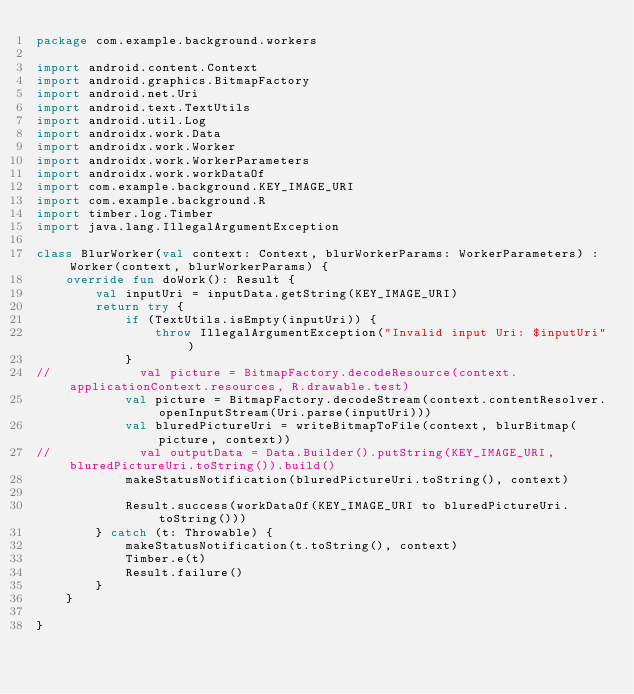<code> <loc_0><loc_0><loc_500><loc_500><_Kotlin_>package com.example.background.workers

import android.content.Context
import android.graphics.BitmapFactory
import android.net.Uri
import android.text.TextUtils
import android.util.Log
import androidx.work.Data
import androidx.work.Worker
import androidx.work.WorkerParameters
import androidx.work.workDataOf
import com.example.background.KEY_IMAGE_URI
import com.example.background.R
import timber.log.Timber
import java.lang.IllegalArgumentException

class BlurWorker(val context: Context, blurWorkerParams: WorkerParameters) : Worker(context, blurWorkerParams) {
    override fun doWork(): Result {
        val inputUri = inputData.getString(KEY_IMAGE_URI)
        return try {
            if (TextUtils.isEmpty(inputUri)) {
                throw IllegalArgumentException("Invalid input Uri: $inputUri")
            }
//            val picture = BitmapFactory.decodeResource(context.applicationContext.resources, R.drawable.test)
            val picture = BitmapFactory.decodeStream(context.contentResolver.openInputStream(Uri.parse(inputUri)))
            val bluredPictureUri = writeBitmapToFile(context, blurBitmap(picture, context))
//            val outputData = Data.Builder().putString(KEY_IMAGE_URI,bluredPictureUri.toString()).build()
            makeStatusNotification(bluredPictureUri.toString(), context)

            Result.success(workDataOf(KEY_IMAGE_URI to bluredPictureUri.toString()))
        } catch (t: Throwable) {
            makeStatusNotification(t.toString(), context)
            Timber.e(t)
            Result.failure()
        }
    }

}</code> 